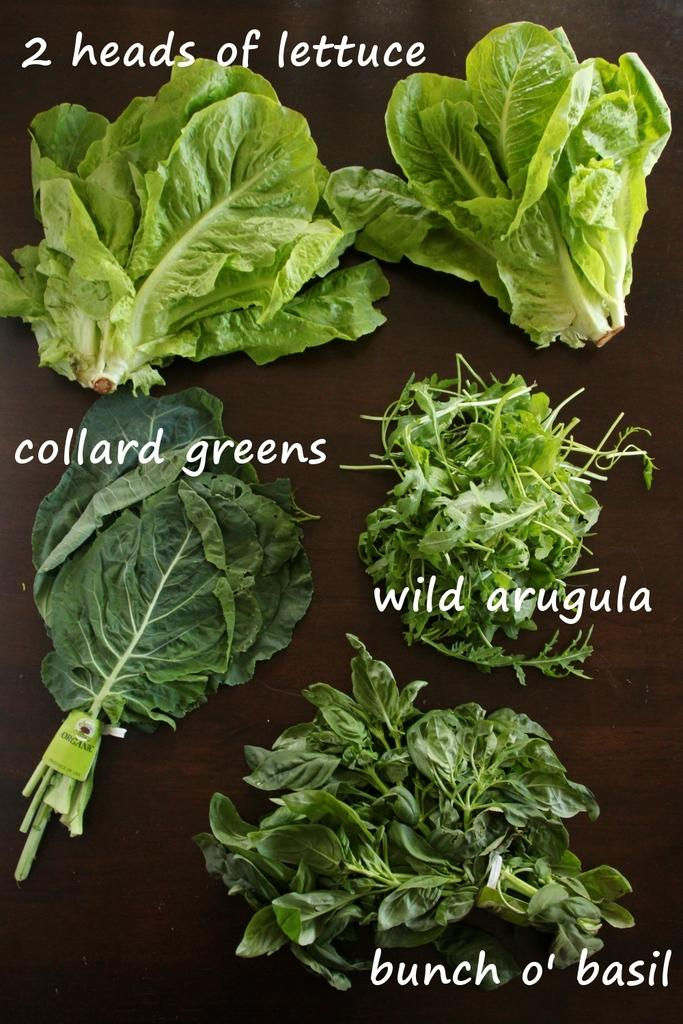What types of leafy greens are visible in the image? There are two heads of lettuce, collard greens, wild arugula, and a bunch of basil in the image. Can you describe the different types of greens in more detail? The two heads of lettuce are likely a type of lettuce, while collard greens are a leafy green vegetable with large, dark green leaves. Wild arugula is a spicy, peppery green, and basil is an aromatic herb with green leaves. What mark can be seen on the downtown idea in the image? There is no mention of a mark, downtown, or idea in the image. The image only features various types of leafy greens. 